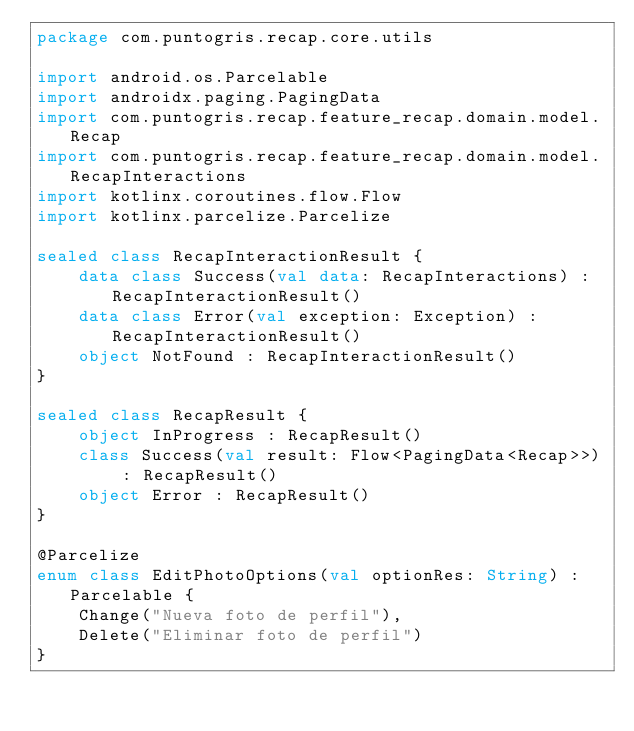Convert code to text. <code><loc_0><loc_0><loc_500><loc_500><_Kotlin_>package com.puntogris.recap.core.utils

import android.os.Parcelable
import androidx.paging.PagingData
import com.puntogris.recap.feature_recap.domain.model.Recap
import com.puntogris.recap.feature_recap.domain.model.RecapInteractions
import kotlinx.coroutines.flow.Flow
import kotlinx.parcelize.Parcelize

sealed class RecapInteractionResult {
    data class Success(val data: RecapInteractions) : RecapInteractionResult()
    data class Error(val exception: Exception) : RecapInteractionResult()
    object NotFound : RecapInteractionResult()
}

sealed class RecapResult {
    object InProgress : RecapResult()
    class Success(val result: Flow<PagingData<Recap>>) : RecapResult()
    object Error : RecapResult()
}

@Parcelize
enum class EditPhotoOptions(val optionRes: String) : Parcelable {
    Change("Nueva foto de perfil"),
    Delete("Eliminar foto de perfil")
}
</code> 